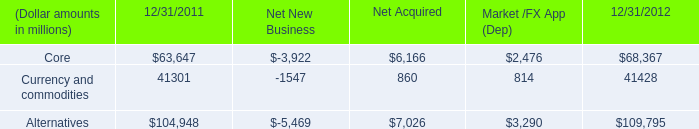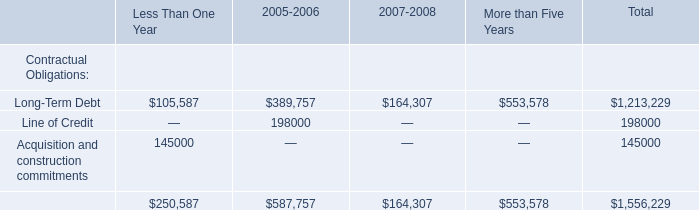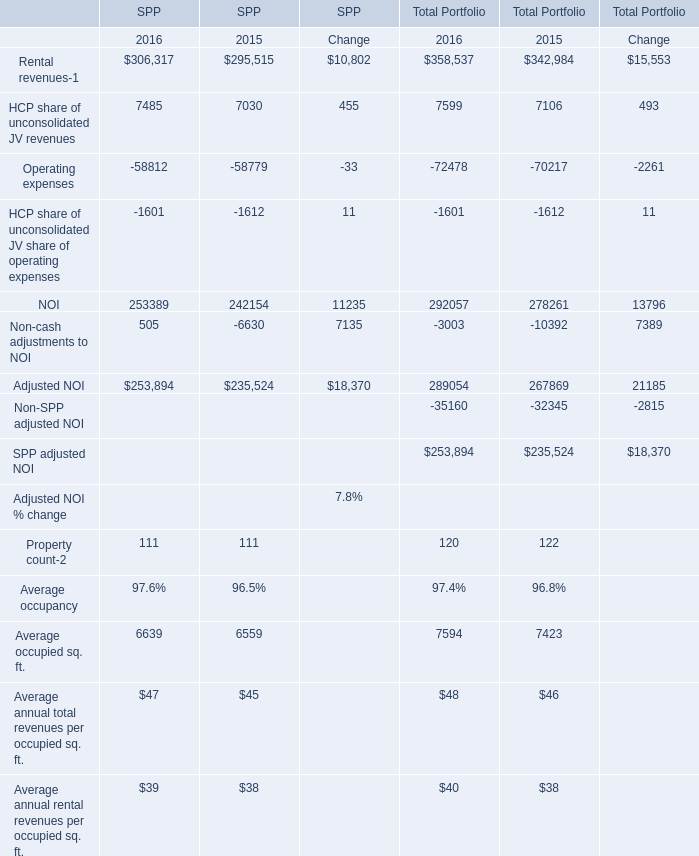What is the percentage of Rental revenues-1 in relation to the total in 2016? 
Computations: ((306317 + 358537) / (253894 + 253894))
Answer: 1.30931. 